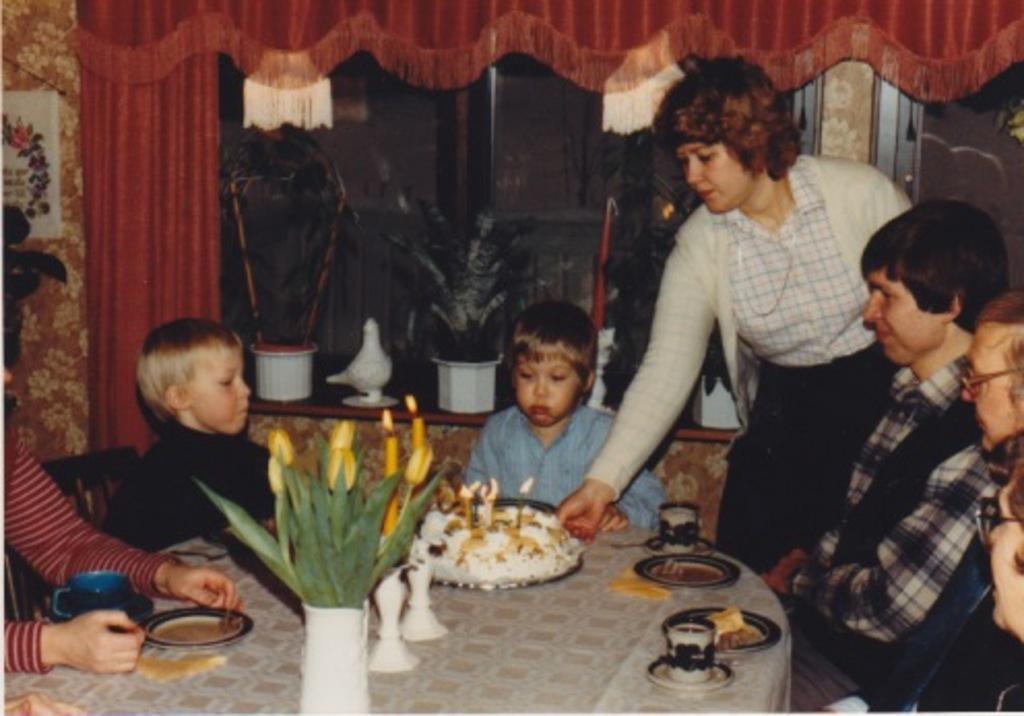Please provide a concise description of this image. In this image there are four people and two children. In front of the children there is a table on the table there is a cake,flower pot,saucer,cup and a cloth on it. At the background there is a window and a curtain. 